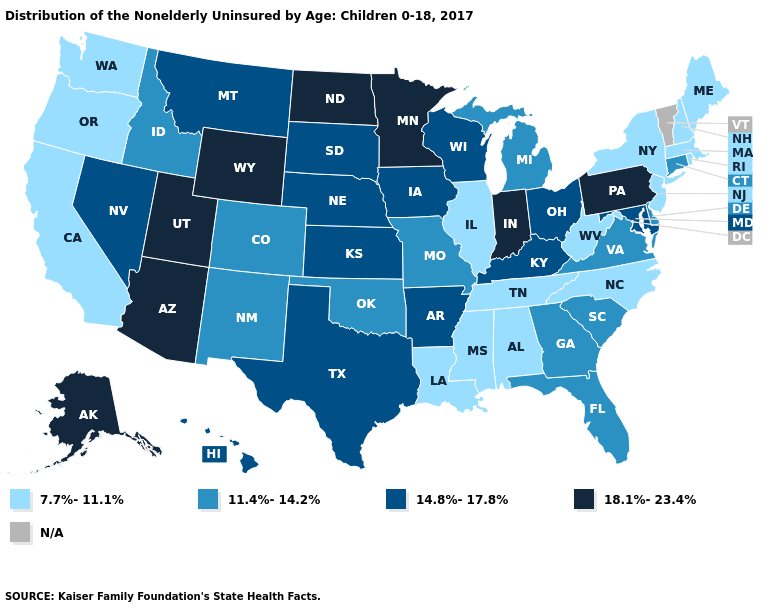What is the value of Connecticut?
Answer briefly. 11.4%-14.2%. What is the highest value in the West ?
Quick response, please. 18.1%-23.4%. Does the first symbol in the legend represent the smallest category?
Quick response, please. Yes. What is the value of Maryland?
Write a very short answer. 14.8%-17.8%. What is the highest value in the West ?
Concise answer only. 18.1%-23.4%. Which states have the lowest value in the USA?
Be succinct. Alabama, California, Illinois, Louisiana, Maine, Massachusetts, Mississippi, New Hampshire, New Jersey, New York, North Carolina, Oregon, Rhode Island, Tennessee, Washington, West Virginia. What is the lowest value in states that border Pennsylvania?
Quick response, please. 7.7%-11.1%. Which states have the lowest value in the USA?
Give a very brief answer. Alabama, California, Illinois, Louisiana, Maine, Massachusetts, Mississippi, New Hampshire, New Jersey, New York, North Carolina, Oregon, Rhode Island, Tennessee, Washington, West Virginia. What is the value of New York?
Quick response, please. 7.7%-11.1%. What is the value of Tennessee?
Short answer required. 7.7%-11.1%. Which states hav the highest value in the West?
Write a very short answer. Alaska, Arizona, Utah, Wyoming. Is the legend a continuous bar?
Short answer required. No. Name the states that have a value in the range 11.4%-14.2%?
Concise answer only. Colorado, Connecticut, Delaware, Florida, Georgia, Idaho, Michigan, Missouri, New Mexico, Oklahoma, South Carolina, Virginia. Does Indiana have the highest value in the MidWest?
Concise answer only. Yes. 